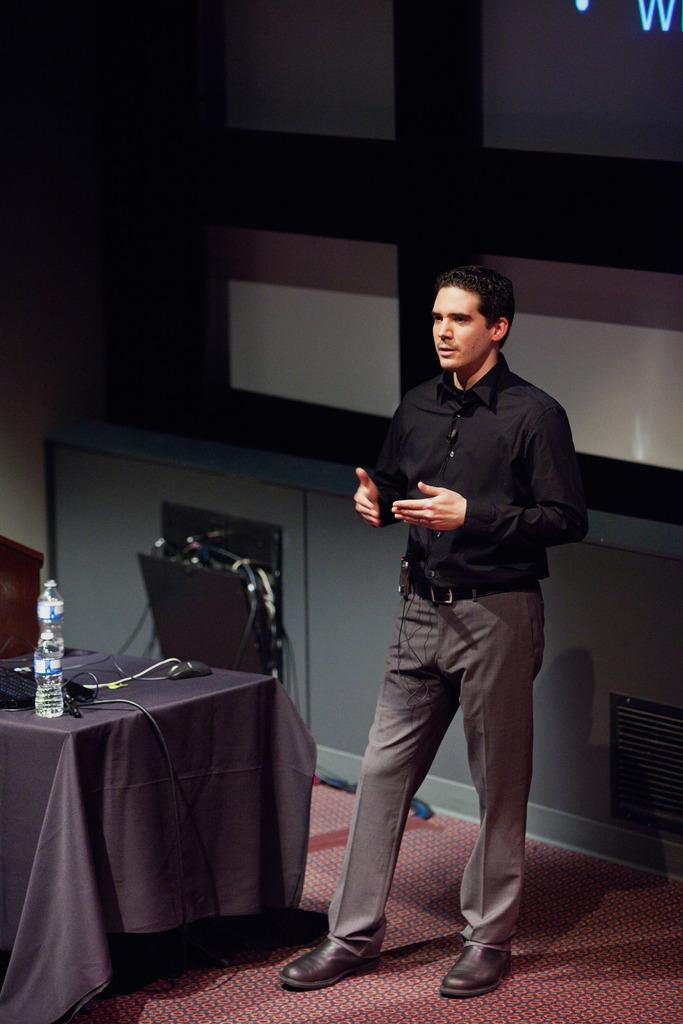How many people are in the image? There are persons standing in the image. What surface are the persons standing on? The persons are standing on the floor. What furniture is present in the image? There is a table in the image. What object is on the table? There is a bottle on the table. Are there any animals in the image? Yes, there is a mouse in the image. What type of guitar is the person playing in the image? There is no guitar present in the image; the persons are simply standing. Can you see the approval rating of the person in the image? There is no indication of an approval rating in the image. 